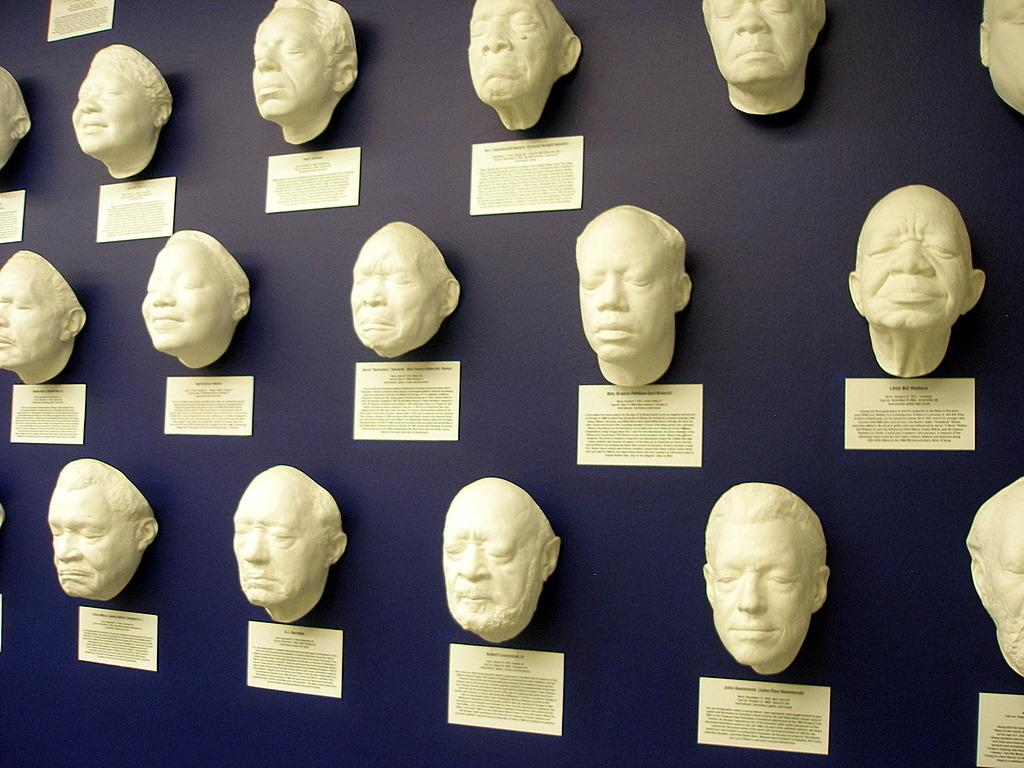What is present on the wall in the image? There are masks and notes on the wall. What type of objects are the masks? The masks are decorative objects on the wall. What can be found on the notes? There is writing on the notes. What beginner level is required to attend the party mentioned on the wall? There is no mention of a party or any level of expertise in the image. 